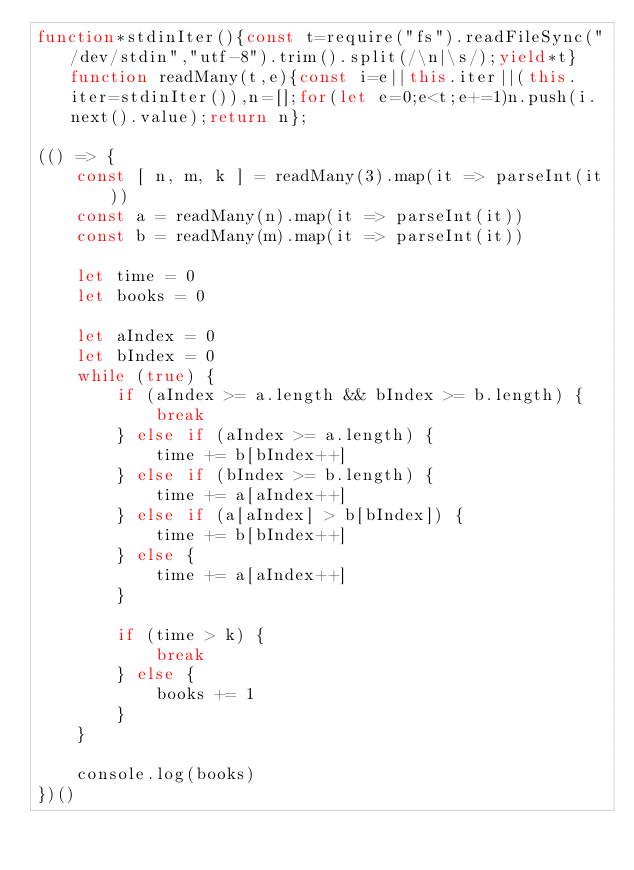<code> <loc_0><loc_0><loc_500><loc_500><_JavaScript_>function*stdinIter(){const t=require("fs").readFileSync("/dev/stdin","utf-8").trim().split(/\n|\s/);yield*t}function readMany(t,e){const i=e||this.iter||(this.iter=stdinIter()),n=[];for(let e=0;e<t;e+=1)n.push(i.next().value);return n};

(() => {
    const [ n, m, k ] = readMany(3).map(it => parseInt(it))
    const a = readMany(n).map(it => parseInt(it))
    const b = readMany(m).map(it => parseInt(it))

    let time = 0
    let books = 0

    let aIndex = 0
    let bIndex = 0
    while (true) {
        if (aIndex >= a.length && bIndex >= b.length) {
            break
        } else if (aIndex >= a.length) {
            time += b[bIndex++]
        } else if (bIndex >= b.length) {
            time += a[aIndex++]
        } else if (a[aIndex] > b[bIndex]) {
            time += b[bIndex++]
        } else {
            time += a[aIndex++]
        }

        if (time > k) {
            break
        } else {
            books += 1
        }
    }

    console.log(books)
})()
</code> 